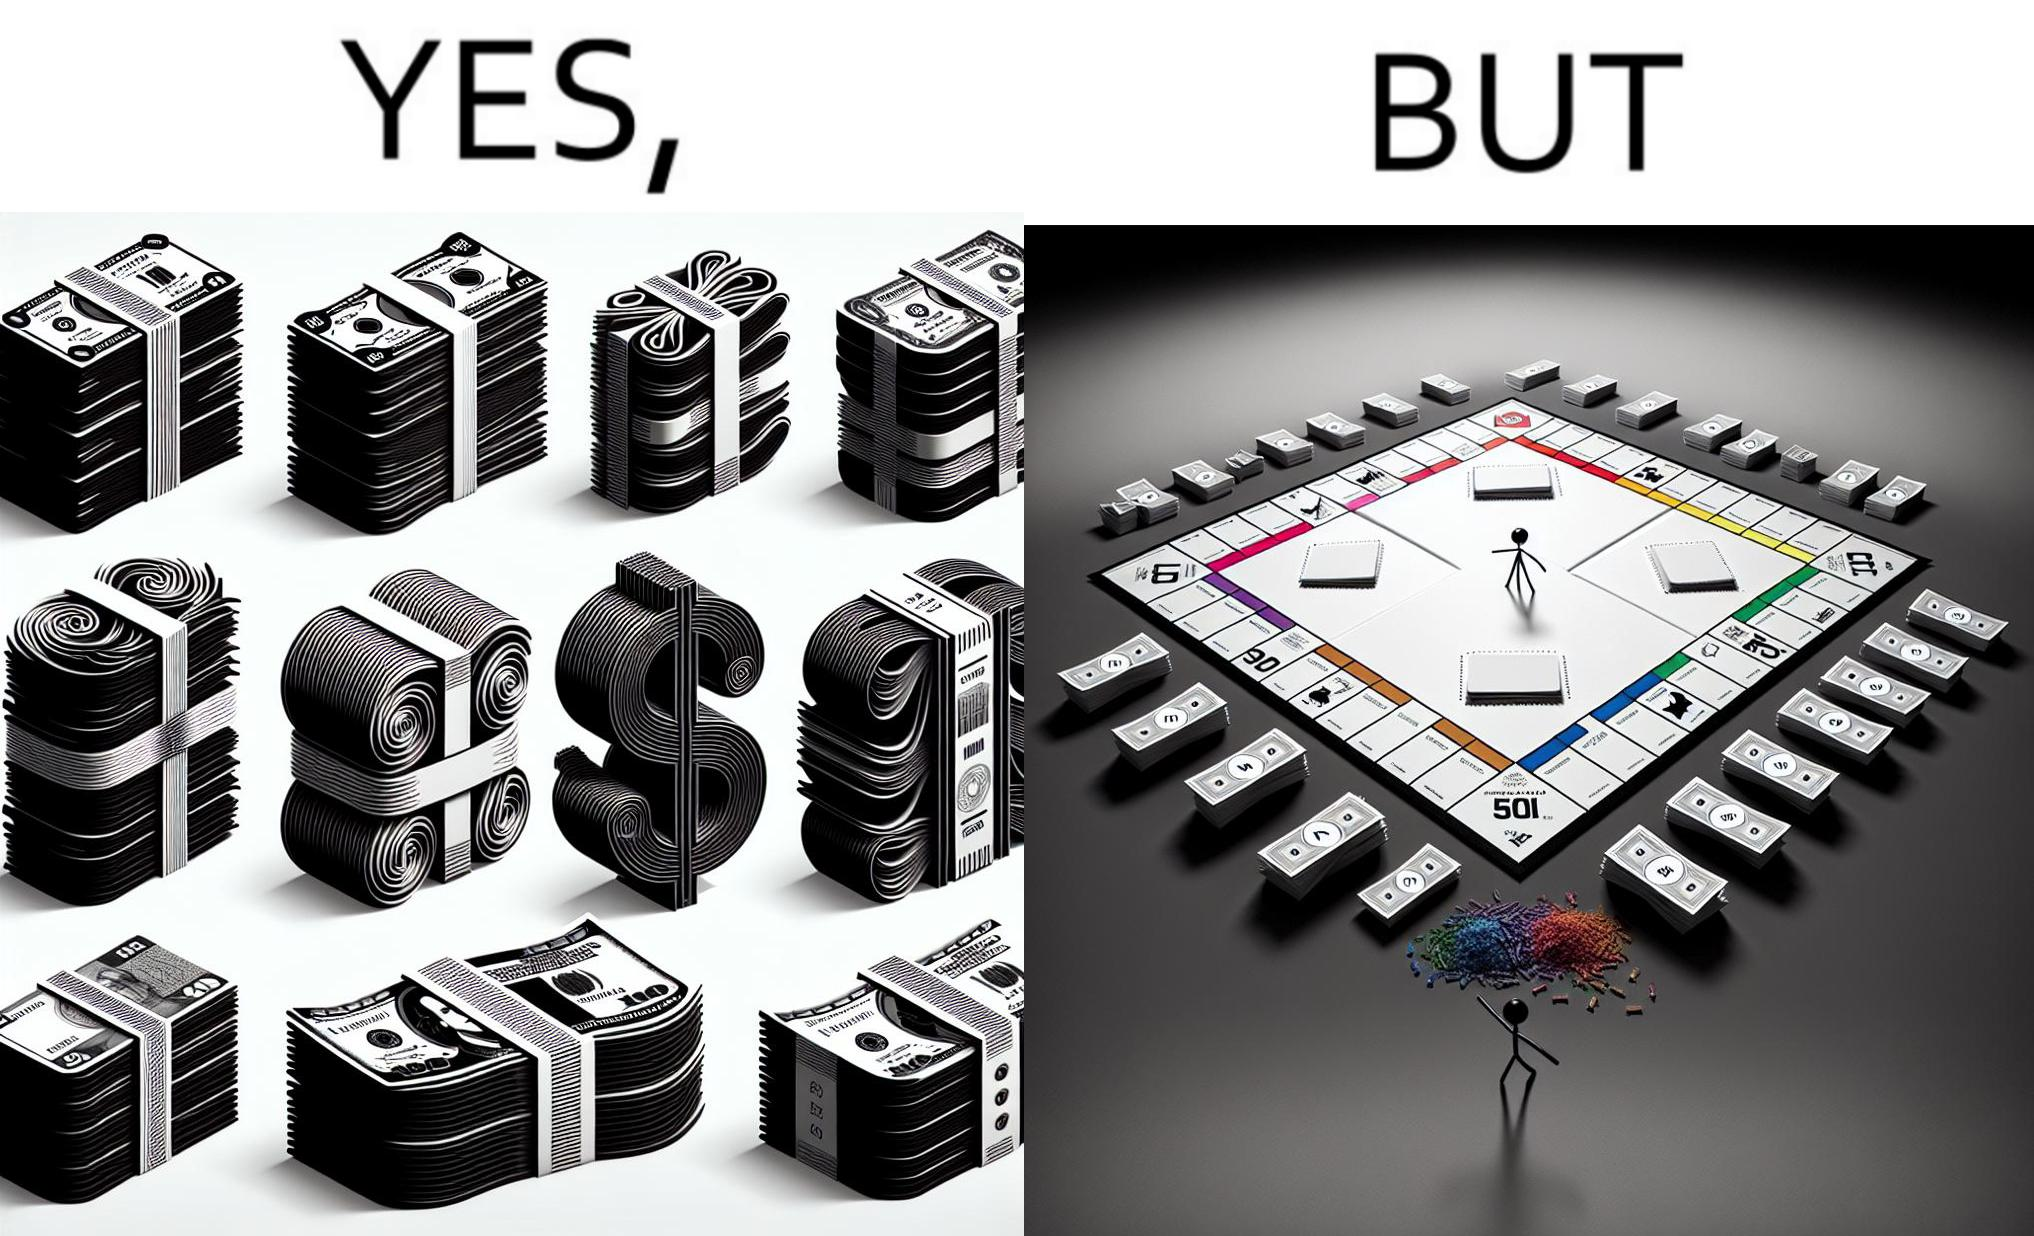Is there satirical content in this image? Yes, this image is satirical. 